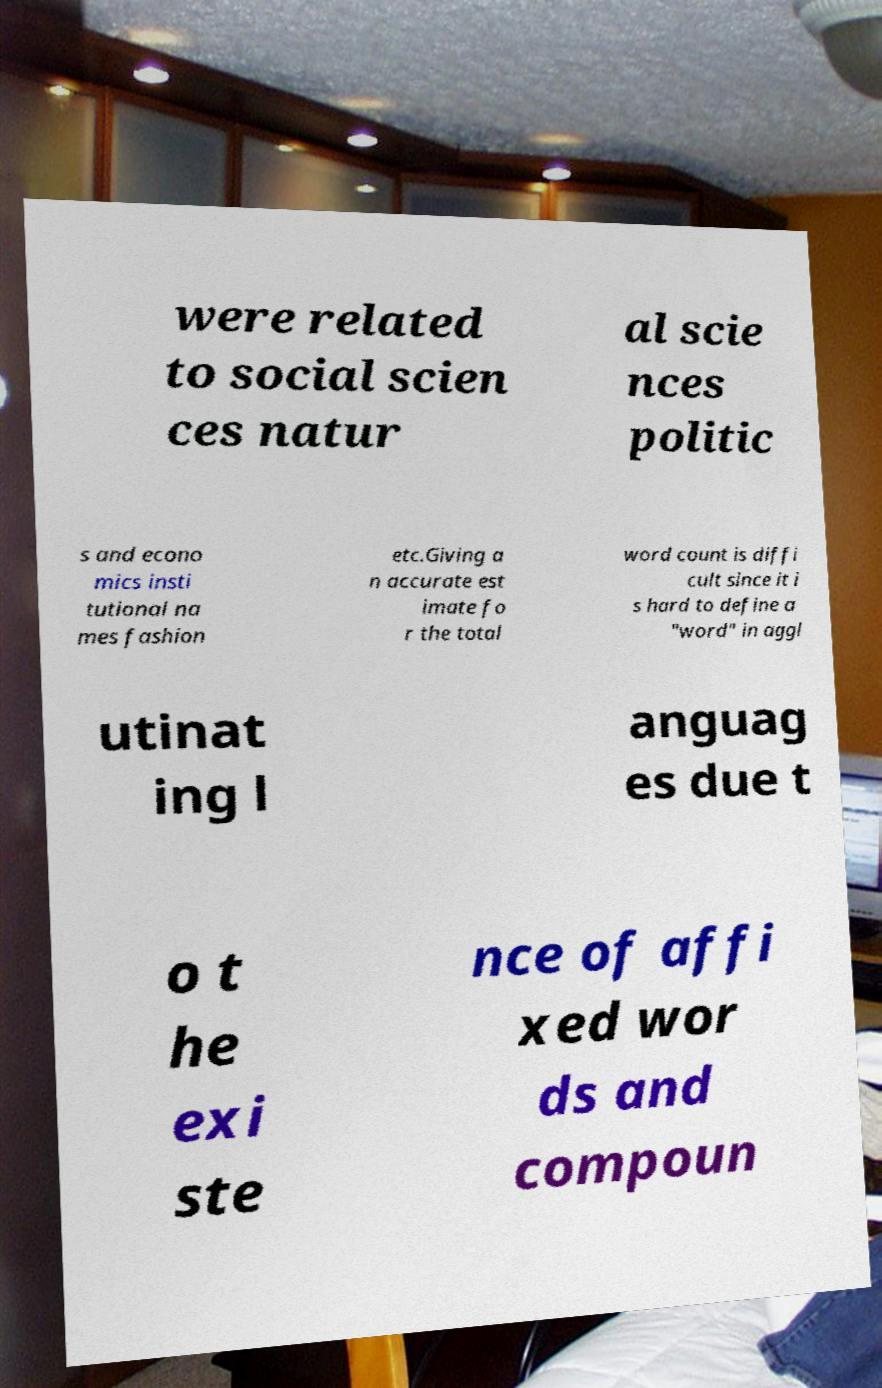Can you read and provide the text displayed in the image?This photo seems to have some interesting text. Can you extract and type it out for me? were related to social scien ces natur al scie nces politic s and econo mics insti tutional na mes fashion etc.Giving a n accurate est imate fo r the total word count is diffi cult since it i s hard to define a "word" in aggl utinat ing l anguag es due t o t he exi ste nce of affi xed wor ds and compoun 